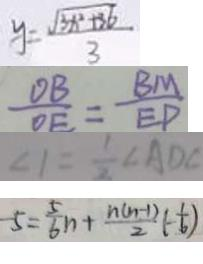<formula> <loc_0><loc_0><loc_500><loc_500>y = \frac { \sqrt { 3 x ^ { 2 } + 3 6 } } { 3 } 
 \frac { O B } { O E } = \frac { B M } { E P } 
 \angle 1 = \frac { 1 } { 2 } \angle A D C 
 - 5 = \frac { 5 } { 6 } n + \frac { n ( n - 1 ) } { 2 } ( - \frac { 1 } { 6 } )</formula> 